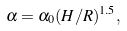Convert formula to latex. <formula><loc_0><loc_0><loc_500><loc_500>\alpha = \alpha _ { 0 } ( H / R ) ^ { 1 . 5 } ,</formula> 